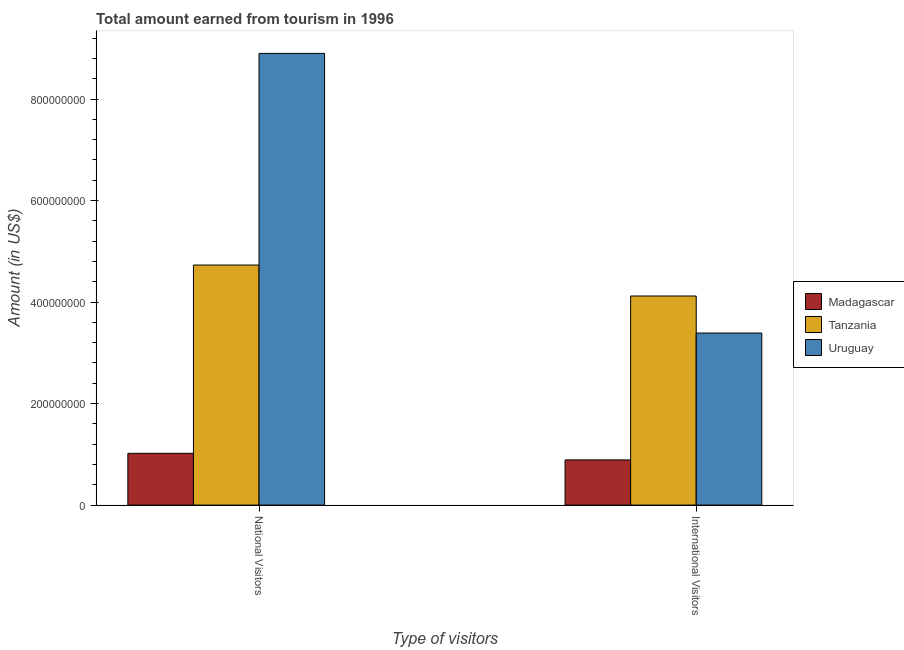How many different coloured bars are there?
Make the answer very short. 3. Are the number of bars per tick equal to the number of legend labels?
Offer a very short reply. Yes. What is the label of the 1st group of bars from the left?
Provide a short and direct response. National Visitors. What is the amount earned from international visitors in Uruguay?
Your answer should be very brief. 3.39e+08. Across all countries, what is the maximum amount earned from international visitors?
Keep it short and to the point. 4.12e+08. Across all countries, what is the minimum amount earned from national visitors?
Offer a terse response. 1.02e+08. In which country was the amount earned from national visitors maximum?
Your response must be concise. Uruguay. In which country was the amount earned from national visitors minimum?
Your answer should be very brief. Madagascar. What is the total amount earned from national visitors in the graph?
Provide a short and direct response. 1.46e+09. What is the difference between the amount earned from national visitors in Tanzania and that in Uruguay?
Give a very brief answer. -4.17e+08. What is the difference between the amount earned from national visitors in Madagascar and the amount earned from international visitors in Tanzania?
Your response must be concise. -3.10e+08. What is the average amount earned from international visitors per country?
Offer a terse response. 2.80e+08. What is the difference between the amount earned from international visitors and amount earned from national visitors in Tanzania?
Offer a terse response. -6.10e+07. What is the ratio of the amount earned from international visitors in Uruguay to that in Madagascar?
Ensure brevity in your answer.  3.81. Is the amount earned from international visitors in Madagascar less than that in Uruguay?
Keep it short and to the point. Yes. In how many countries, is the amount earned from international visitors greater than the average amount earned from international visitors taken over all countries?
Your answer should be very brief. 2. What does the 3rd bar from the left in International Visitors represents?
Offer a terse response. Uruguay. What does the 2nd bar from the right in International Visitors represents?
Ensure brevity in your answer.  Tanzania. Are all the bars in the graph horizontal?
Ensure brevity in your answer.  No. Does the graph contain any zero values?
Offer a terse response. No. Does the graph contain grids?
Give a very brief answer. No. Where does the legend appear in the graph?
Provide a short and direct response. Center right. How many legend labels are there?
Provide a short and direct response. 3. How are the legend labels stacked?
Give a very brief answer. Vertical. What is the title of the graph?
Your answer should be compact. Total amount earned from tourism in 1996. Does "Netherlands" appear as one of the legend labels in the graph?
Keep it short and to the point. No. What is the label or title of the X-axis?
Your response must be concise. Type of visitors. What is the label or title of the Y-axis?
Offer a terse response. Amount (in US$). What is the Amount (in US$) in Madagascar in National Visitors?
Offer a terse response. 1.02e+08. What is the Amount (in US$) of Tanzania in National Visitors?
Offer a terse response. 4.73e+08. What is the Amount (in US$) of Uruguay in National Visitors?
Your response must be concise. 8.90e+08. What is the Amount (in US$) of Madagascar in International Visitors?
Offer a very short reply. 8.90e+07. What is the Amount (in US$) in Tanzania in International Visitors?
Ensure brevity in your answer.  4.12e+08. What is the Amount (in US$) in Uruguay in International Visitors?
Ensure brevity in your answer.  3.39e+08. Across all Type of visitors, what is the maximum Amount (in US$) of Madagascar?
Offer a terse response. 1.02e+08. Across all Type of visitors, what is the maximum Amount (in US$) in Tanzania?
Keep it short and to the point. 4.73e+08. Across all Type of visitors, what is the maximum Amount (in US$) of Uruguay?
Keep it short and to the point. 8.90e+08. Across all Type of visitors, what is the minimum Amount (in US$) in Madagascar?
Your answer should be very brief. 8.90e+07. Across all Type of visitors, what is the minimum Amount (in US$) of Tanzania?
Provide a short and direct response. 4.12e+08. Across all Type of visitors, what is the minimum Amount (in US$) of Uruguay?
Provide a short and direct response. 3.39e+08. What is the total Amount (in US$) in Madagascar in the graph?
Offer a very short reply. 1.91e+08. What is the total Amount (in US$) in Tanzania in the graph?
Make the answer very short. 8.85e+08. What is the total Amount (in US$) of Uruguay in the graph?
Give a very brief answer. 1.23e+09. What is the difference between the Amount (in US$) of Madagascar in National Visitors and that in International Visitors?
Offer a terse response. 1.30e+07. What is the difference between the Amount (in US$) in Tanzania in National Visitors and that in International Visitors?
Offer a terse response. 6.10e+07. What is the difference between the Amount (in US$) of Uruguay in National Visitors and that in International Visitors?
Offer a terse response. 5.51e+08. What is the difference between the Amount (in US$) of Madagascar in National Visitors and the Amount (in US$) of Tanzania in International Visitors?
Offer a terse response. -3.10e+08. What is the difference between the Amount (in US$) in Madagascar in National Visitors and the Amount (in US$) in Uruguay in International Visitors?
Offer a terse response. -2.37e+08. What is the difference between the Amount (in US$) of Tanzania in National Visitors and the Amount (in US$) of Uruguay in International Visitors?
Offer a very short reply. 1.34e+08. What is the average Amount (in US$) in Madagascar per Type of visitors?
Your response must be concise. 9.55e+07. What is the average Amount (in US$) of Tanzania per Type of visitors?
Keep it short and to the point. 4.42e+08. What is the average Amount (in US$) in Uruguay per Type of visitors?
Provide a succinct answer. 6.14e+08. What is the difference between the Amount (in US$) of Madagascar and Amount (in US$) of Tanzania in National Visitors?
Provide a succinct answer. -3.71e+08. What is the difference between the Amount (in US$) of Madagascar and Amount (in US$) of Uruguay in National Visitors?
Your answer should be very brief. -7.88e+08. What is the difference between the Amount (in US$) of Tanzania and Amount (in US$) of Uruguay in National Visitors?
Your response must be concise. -4.17e+08. What is the difference between the Amount (in US$) in Madagascar and Amount (in US$) in Tanzania in International Visitors?
Your answer should be compact. -3.23e+08. What is the difference between the Amount (in US$) in Madagascar and Amount (in US$) in Uruguay in International Visitors?
Provide a short and direct response. -2.50e+08. What is the difference between the Amount (in US$) in Tanzania and Amount (in US$) in Uruguay in International Visitors?
Your answer should be compact. 7.30e+07. What is the ratio of the Amount (in US$) of Madagascar in National Visitors to that in International Visitors?
Offer a very short reply. 1.15. What is the ratio of the Amount (in US$) in Tanzania in National Visitors to that in International Visitors?
Ensure brevity in your answer.  1.15. What is the ratio of the Amount (in US$) in Uruguay in National Visitors to that in International Visitors?
Provide a short and direct response. 2.63. What is the difference between the highest and the second highest Amount (in US$) of Madagascar?
Keep it short and to the point. 1.30e+07. What is the difference between the highest and the second highest Amount (in US$) in Tanzania?
Provide a short and direct response. 6.10e+07. What is the difference between the highest and the second highest Amount (in US$) of Uruguay?
Your answer should be compact. 5.51e+08. What is the difference between the highest and the lowest Amount (in US$) of Madagascar?
Your answer should be compact. 1.30e+07. What is the difference between the highest and the lowest Amount (in US$) in Tanzania?
Offer a very short reply. 6.10e+07. What is the difference between the highest and the lowest Amount (in US$) of Uruguay?
Ensure brevity in your answer.  5.51e+08. 